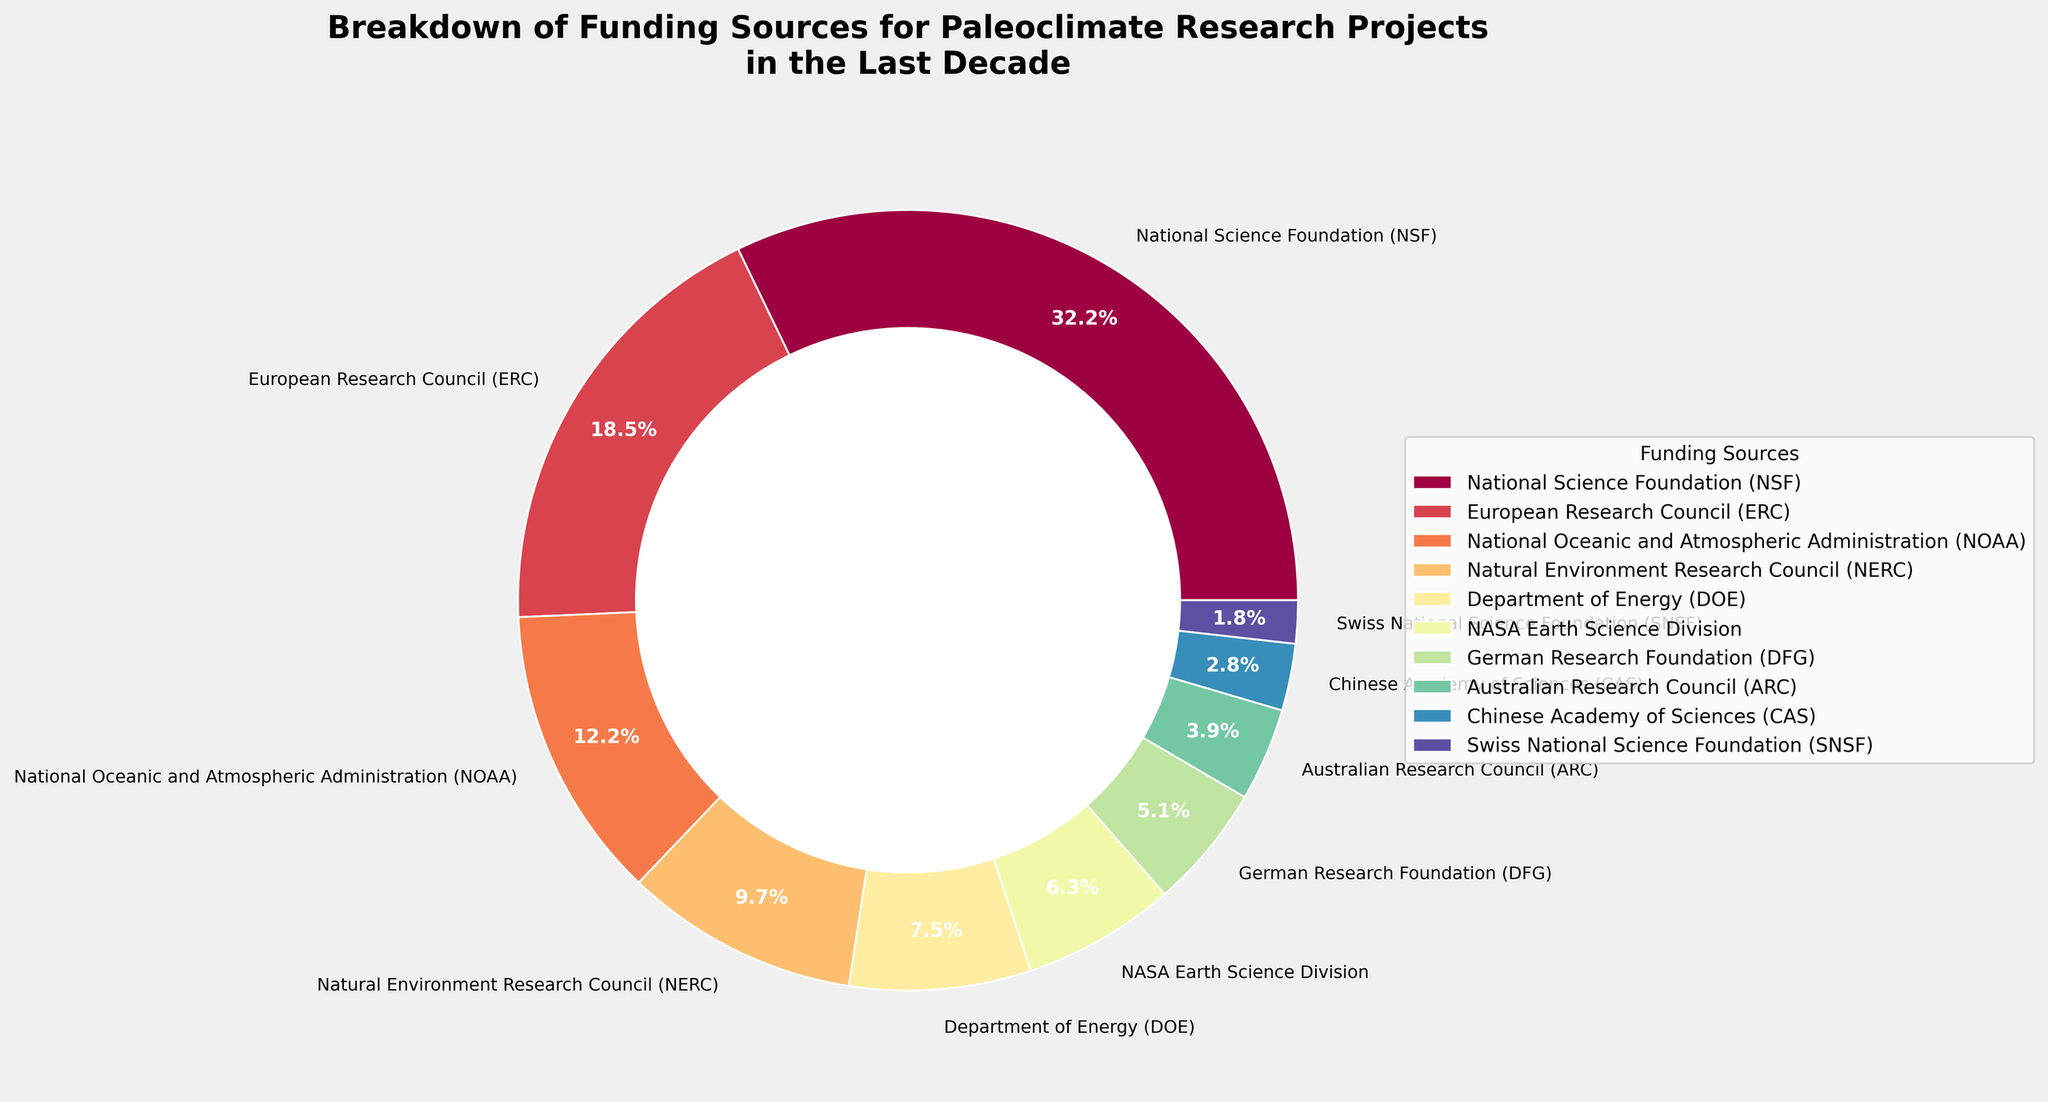What is the funding percentage contributed by the top two sources combined? The top two sources are the National Science Foundation (NSF) with 32.5% and the European Research Council (ERC) with 18.7%. Adding these together gives 32.5 + 18.7 = 51.2.
Answer: 51.2% Which organization contributes more to paleoclimate research, NOAA or NASA Earth Science Division? The National Oceanic and Atmospheric Administration (NOAA) contributes 12.3%, whereas NASA Earth Science Division contributes 6.4%. 12.3% is greater than 6.4%.
Answer: NOAA Is the funding from the German Research Foundation (DFG) greater than that of the Australian Research Council (ARC)? The German Research Foundation (DFG) contributes 5.2% and the Australian Research Council (ARC) contributes 3.9%. 5.2% is greater than 3.9%.
Answer: Yes How much more funding does the NSF provide compared to the Department of Energy (DOE)? The National Science Foundation (NSF) provides 32.5% and the Department of Energy (DOE) provides 7.6%. The difference is 32.5 - 7.6 = 24.9.
Answer: 24.9% Which funding source has the smallest contribution, and what is its percentage? The Swiss National Science Foundation (SNSF) has the smallest contribution at 1.8% as seen from the figure.
Answer: Swiss National Science Foundation (SNSF), 1.8% What is the combined funding percentage of non-European sources? Non-European sources are NSF (32.5%), NOAA (12.3%), DOE (7.6%), NASA Earth Science Division (6.4%), Australian Research Council (ARC) (3.9%), and Chinese Academy of Sciences (CAS) (2.8%). Adding these gives 32.5 + 12.3 + 7.6 + 6.4 + 3.9 + 2.8 = 65.5.
Answer: 65.5% What is the difference in funding percentage between the highest and lowest contributors? The highest is NSF with 32.5% and the lowest is SNSF with 1.8%. The difference is 32.5 - 1.8 = 30.7.
Answer: 30.7% Which three organizations contribute a total of around one-third of the funding? The National Science Foundation (NSF) contributes 32.5%. This is slightly more than one-third. NSF alone contributes around one-third to the funding.
Answer: NSF 